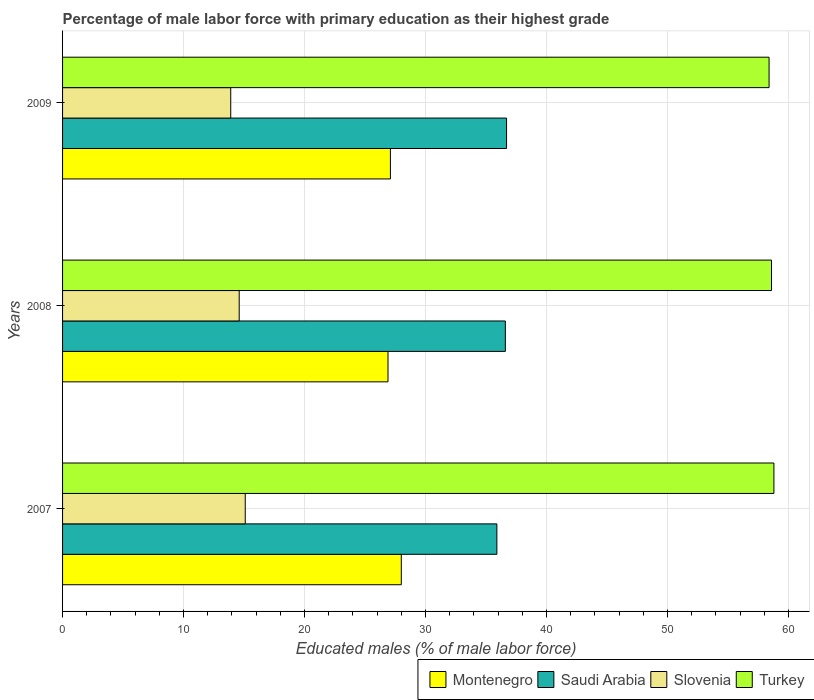How many different coloured bars are there?
Ensure brevity in your answer.  4. How many groups of bars are there?
Offer a very short reply. 3. How many bars are there on the 1st tick from the top?
Provide a short and direct response. 4. What is the label of the 3rd group of bars from the top?
Ensure brevity in your answer.  2007. In how many cases, is the number of bars for a given year not equal to the number of legend labels?
Your answer should be compact. 0. What is the percentage of male labor force with primary education in Turkey in 2008?
Ensure brevity in your answer.  58.6. Across all years, what is the maximum percentage of male labor force with primary education in Montenegro?
Provide a short and direct response. 28. Across all years, what is the minimum percentage of male labor force with primary education in Turkey?
Offer a terse response. 58.4. What is the total percentage of male labor force with primary education in Turkey in the graph?
Ensure brevity in your answer.  175.8. What is the difference between the percentage of male labor force with primary education in Turkey in 2007 and that in 2009?
Offer a very short reply. 0.4. What is the difference between the percentage of male labor force with primary education in Montenegro in 2008 and the percentage of male labor force with primary education in Slovenia in 2007?
Offer a terse response. 11.8. What is the average percentage of male labor force with primary education in Slovenia per year?
Ensure brevity in your answer.  14.53. In the year 2007, what is the difference between the percentage of male labor force with primary education in Saudi Arabia and percentage of male labor force with primary education in Montenegro?
Offer a terse response. 7.9. In how many years, is the percentage of male labor force with primary education in Saudi Arabia greater than 44 %?
Ensure brevity in your answer.  0. What is the ratio of the percentage of male labor force with primary education in Turkey in 2007 to that in 2008?
Give a very brief answer. 1. Is the percentage of male labor force with primary education in Montenegro in 2008 less than that in 2009?
Your answer should be very brief. Yes. Is the difference between the percentage of male labor force with primary education in Saudi Arabia in 2007 and 2008 greater than the difference between the percentage of male labor force with primary education in Montenegro in 2007 and 2008?
Offer a terse response. No. What is the difference between the highest and the second highest percentage of male labor force with primary education in Turkey?
Provide a short and direct response. 0.2. What is the difference between the highest and the lowest percentage of male labor force with primary education in Slovenia?
Your answer should be compact. 1.2. Is the sum of the percentage of male labor force with primary education in Montenegro in 2008 and 2009 greater than the maximum percentage of male labor force with primary education in Saudi Arabia across all years?
Give a very brief answer. Yes. What does the 4th bar from the top in 2009 represents?
Offer a terse response. Montenegro. What does the 2nd bar from the bottom in 2009 represents?
Provide a short and direct response. Saudi Arabia. Is it the case that in every year, the sum of the percentage of male labor force with primary education in Turkey and percentage of male labor force with primary education in Slovenia is greater than the percentage of male labor force with primary education in Montenegro?
Keep it short and to the point. Yes. Are all the bars in the graph horizontal?
Provide a succinct answer. Yes. How many years are there in the graph?
Offer a terse response. 3. What is the difference between two consecutive major ticks on the X-axis?
Make the answer very short. 10. Are the values on the major ticks of X-axis written in scientific E-notation?
Your response must be concise. No. Where does the legend appear in the graph?
Keep it short and to the point. Bottom right. What is the title of the graph?
Provide a short and direct response. Percentage of male labor force with primary education as their highest grade. What is the label or title of the X-axis?
Your answer should be compact. Educated males (% of male labor force). What is the Educated males (% of male labor force) of Montenegro in 2007?
Your answer should be very brief. 28. What is the Educated males (% of male labor force) of Saudi Arabia in 2007?
Ensure brevity in your answer.  35.9. What is the Educated males (% of male labor force) of Slovenia in 2007?
Your answer should be very brief. 15.1. What is the Educated males (% of male labor force) of Turkey in 2007?
Give a very brief answer. 58.8. What is the Educated males (% of male labor force) of Montenegro in 2008?
Your response must be concise. 26.9. What is the Educated males (% of male labor force) in Saudi Arabia in 2008?
Your response must be concise. 36.6. What is the Educated males (% of male labor force) in Slovenia in 2008?
Provide a short and direct response. 14.6. What is the Educated males (% of male labor force) in Turkey in 2008?
Offer a very short reply. 58.6. What is the Educated males (% of male labor force) of Montenegro in 2009?
Your response must be concise. 27.1. What is the Educated males (% of male labor force) of Saudi Arabia in 2009?
Make the answer very short. 36.7. What is the Educated males (% of male labor force) in Slovenia in 2009?
Make the answer very short. 13.9. What is the Educated males (% of male labor force) in Turkey in 2009?
Ensure brevity in your answer.  58.4. Across all years, what is the maximum Educated males (% of male labor force) of Montenegro?
Provide a short and direct response. 28. Across all years, what is the maximum Educated males (% of male labor force) of Saudi Arabia?
Ensure brevity in your answer.  36.7. Across all years, what is the maximum Educated males (% of male labor force) of Slovenia?
Your response must be concise. 15.1. Across all years, what is the maximum Educated males (% of male labor force) of Turkey?
Offer a very short reply. 58.8. Across all years, what is the minimum Educated males (% of male labor force) of Montenegro?
Keep it short and to the point. 26.9. Across all years, what is the minimum Educated males (% of male labor force) of Saudi Arabia?
Offer a very short reply. 35.9. Across all years, what is the minimum Educated males (% of male labor force) of Slovenia?
Keep it short and to the point. 13.9. Across all years, what is the minimum Educated males (% of male labor force) in Turkey?
Keep it short and to the point. 58.4. What is the total Educated males (% of male labor force) of Montenegro in the graph?
Keep it short and to the point. 82. What is the total Educated males (% of male labor force) of Saudi Arabia in the graph?
Offer a very short reply. 109.2. What is the total Educated males (% of male labor force) in Slovenia in the graph?
Your response must be concise. 43.6. What is the total Educated males (% of male labor force) in Turkey in the graph?
Your answer should be compact. 175.8. What is the difference between the Educated males (% of male labor force) of Slovenia in 2007 and that in 2008?
Your answer should be compact. 0.5. What is the difference between the Educated males (% of male labor force) of Turkey in 2007 and that in 2008?
Your answer should be compact. 0.2. What is the difference between the Educated males (% of male labor force) in Montenegro in 2007 and that in 2009?
Give a very brief answer. 0.9. What is the difference between the Educated males (% of male labor force) of Slovenia in 2007 and that in 2009?
Provide a succinct answer. 1.2. What is the difference between the Educated males (% of male labor force) in Turkey in 2007 and that in 2009?
Provide a short and direct response. 0.4. What is the difference between the Educated males (% of male labor force) in Saudi Arabia in 2008 and that in 2009?
Your response must be concise. -0.1. What is the difference between the Educated males (% of male labor force) of Slovenia in 2008 and that in 2009?
Offer a very short reply. 0.7. What is the difference between the Educated males (% of male labor force) in Turkey in 2008 and that in 2009?
Offer a terse response. 0.2. What is the difference between the Educated males (% of male labor force) in Montenegro in 2007 and the Educated males (% of male labor force) in Turkey in 2008?
Keep it short and to the point. -30.6. What is the difference between the Educated males (% of male labor force) of Saudi Arabia in 2007 and the Educated males (% of male labor force) of Slovenia in 2008?
Ensure brevity in your answer.  21.3. What is the difference between the Educated males (% of male labor force) in Saudi Arabia in 2007 and the Educated males (% of male labor force) in Turkey in 2008?
Offer a terse response. -22.7. What is the difference between the Educated males (% of male labor force) of Slovenia in 2007 and the Educated males (% of male labor force) of Turkey in 2008?
Your answer should be very brief. -43.5. What is the difference between the Educated males (% of male labor force) in Montenegro in 2007 and the Educated males (% of male labor force) in Saudi Arabia in 2009?
Your answer should be compact. -8.7. What is the difference between the Educated males (% of male labor force) in Montenegro in 2007 and the Educated males (% of male labor force) in Slovenia in 2009?
Make the answer very short. 14.1. What is the difference between the Educated males (% of male labor force) in Montenegro in 2007 and the Educated males (% of male labor force) in Turkey in 2009?
Provide a succinct answer. -30.4. What is the difference between the Educated males (% of male labor force) of Saudi Arabia in 2007 and the Educated males (% of male labor force) of Slovenia in 2009?
Offer a very short reply. 22. What is the difference between the Educated males (% of male labor force) in Saudi Arabia in 2007 and the Educated males (% of male labor force) in Turkey in 2009?
Make the answer very short. -22.5. What is the difference between the Educated males (% of male labor force) of Slovenia in 2007 and the Educated males (% of male labor force) of Turkey in 2009?
Offer a terse response. -43.3. What is the difference between the Educated males (% of male labor force) of Montenegro in 2008 and the Educated males (% of male labor force) of Slovenia in 2009?
Your response must be concise. 13. What is the difference between the Educated males (% of male labor force) of Montenegro in 2008 and the Educated males (% of male labor force) of Turkey in 2009?
Your answer should be compact. -31.5. What is the difference between the Educated males (% of male labor force) in Saudi Arabia in 2008 and the Educated males (% of male labor force) in Slovenia in 2009?
Ensure brevity in your answer.  22.7. What is the difference between the Educated males (% of male labor force) in Saudi Arabia in 2008 and the Educated males (% of male labor force) in Turkey in 2009?
Offer a very short reply. -21.8. What is the difference between the Educated males (% of male labor force) in Slovenia in 2008 and the Educated males (% of male labor force) in Turkey in 2009?
Offer a very short reply. -43.8. What is the average Educated males (% of male labor force) in Montenegro per year?
Provide a succinct answer. 27.33. What is the average Educated males (% of male labor force) of Saudi Arabia per year?
Make the answer very short. 36.4. What is the average Educated males (% of male labor force) of Slovenia per year?
Provide a short and direct response. 14.53. What is the average Educated males (% of male labor force) in Turkey per year?
Keep it short and to the point. 58.6. In the year 2007, what is the difference between the Educated males (% of male labor force) in Montenegro and Educated males (% of male labor force) in Slovenia?
Make the answer very short. 12.9. In the year 2007, what is the difference between the Educated males (% of male labor force) of Montenegro and Educated males (% of male labor force) of Turkey?
Your answer should be very brief. -30.8. In the year 2007, what is the difference between the Educated males (% of male labor force) in Saudi Arabia and Educated males (% of male labor force) in Slovenia?
Provide a succinct answer. 20.8. In the year 2007, what is the difference between the Educated males (% of male labor force) of Saudi Arabia and Educated males (% of male labor force) of Turkey?
Offer a terse response. -22.9. In the year 2007, what is the difference between the Educated males (% of male labor force) in Slovenia and Educated males (% of male labor force) in Turkey?
Ensure brevity in your answer.  -43.7. In the year 2008, what is the difference between the Educated males (% of male labor force) in Montenegro and Educated males (% of male labor force) in Slovenia?
Offer a very short reply. 12.3. In the year 2008, what is the difference between the Educated males (% of male labor force) in Montenegro and Educated males (% of male labor force) in Turkey?
Keep it short and to the point. -31.7. In the year 2008, what is the difference between the Educated males (% of male labor force) of Slovenia and Educated males (% of male labor force) of Turkey?
Your answer should be compact. -44. In the year 2009, what is the difference between the Educated males (% of male labor force) of Montenegro and Educated males (% of male labor force) of Turkey?
Ensure brevity in your answer.  -31.3. In the year 2009, what is the difference between the Educated males (% of male labor force) of Saudi Arabia and Educated males (% of male labor force) of Slovenia?
Make the answer very short. 22.8. In the year 2009, what is the difference between the Educated males (% of male labor force) in Saudi Arabia and Educated males (% of male labor force) in Turkey?
Provide a succinct answer. -21.7. In the year 2009, what is the difference between the Educated males (% of male labor force) of Slovenia and Educated males (% of male labor force) of Turkey?
Make the answer very short. -44.5. What is the ratio of the Educated males (% of male labor force) in Montenegro in 2007 to that in 2008?
Your response must be concise. 1.04. What is the ratio of the Educated males (% of male labor force) in Saudi Arabia in 2007 to that in 2008?
Offer a terse response. 0.98. What is the ratio of the Educated males (% of male labor force) of Slovenia in 2007 to that in 2008?
Offer a very short reply. 1.03. What is the ratio of the Educated males (% of male labor force) of Turkey in 2007 to that in 2008?
Ensure brevity in your answer.  1. What is the ratio of the Educated males (% of male labor force) of Montenegro in 2007 to that in 2009?
Provide a succinct answer. 1.03. What is the ratio of the Educated males (% of male labor force) in Saudi Arabia in 2007 to that in 2009?
Provide a short and direct response. 0.98. What is the ratio of the Educated males (% of male labor force) in Slovenia in 2007 to that in 2009?
Provide a short and direct response. 1.09. What is the ratio of the Educated males (% of male labor force) of Turkey in 2007 to that in 2009?
Give a very brief answer. 1.01. What is the ratio of the Educated males (% of male labor force) in Saudi Arabia in 2008 to that in 2009?
Ensure brevity in your answer.  1. What is the ratio of the Educated males (% of male labor force) in Slovenia in 2008 to that in 2009?
Ensure brevity in your answer.  1.05. What is the ratio of the Educated males (% of male labor force) of Turkey in 2008 to that in 2009?
Ensure brevity in your answer.  1. What is the difference between the highest and the second highest Educated males (% of male labor force) in Montenegro?
Give a very brief answer. 0.9. What is the difference between the highest and the second highest Educated males (% of male labor force) of Saudi Arabia?
Offer a terse response. 0.1. What is the difference between the highest and the second highest Educated males (% of male labor force) of Turkey?
Make the answer very short. 0.2. What is the difference between the highest and the lowest Educated males (% of male labor force) in Saudi Arabia?
Your answer should be compact. 0.8. What is the difference between the highest and the lowest Educated males (% of male labor force) of Slovenia?
Keep it short and to the point. 1.2. 